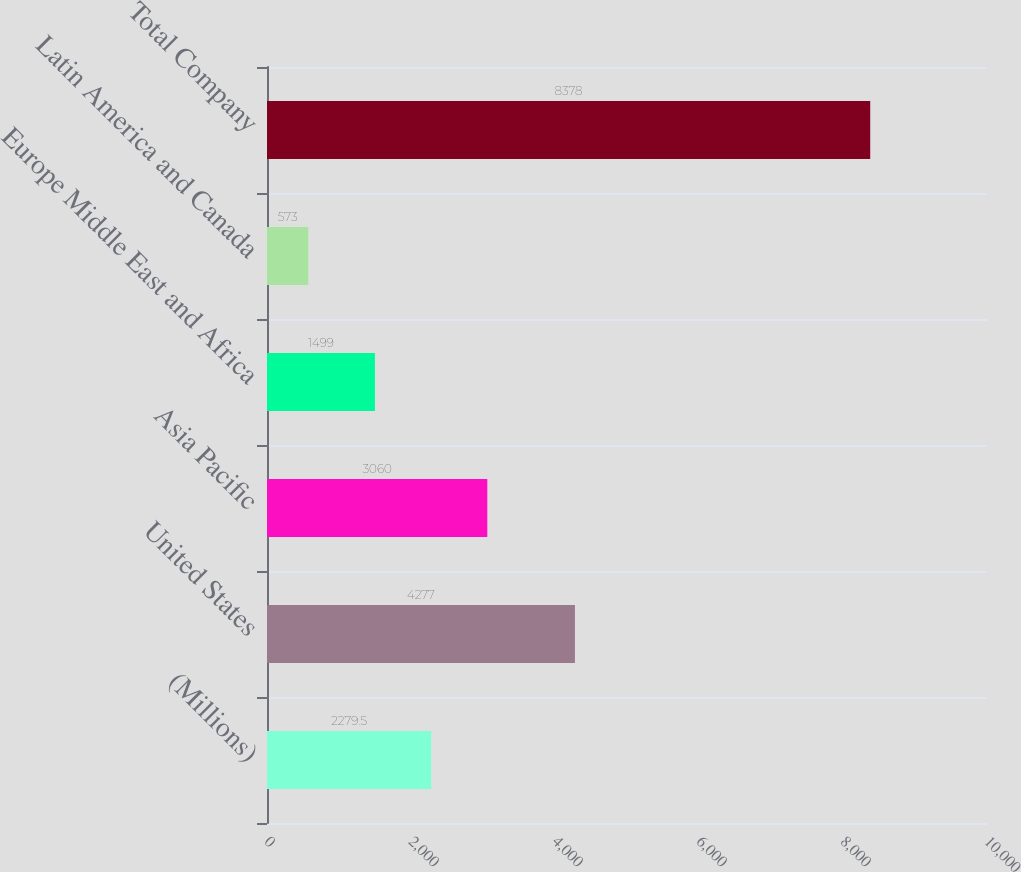Convert chart to OTSL. <chart><loc_0><loc_0><loc_500><loc_500><bar_chart><fcel>(Millions)<fcel>United States<fcel>Asia Pacific<fcel>Europe Middle East and Africa<fcel>Latin America and Canada<fcel>Total Company<nl><fcel>2279.5<fcel>4277<fcel>3060<fcel>1499<fcel>573<fcel>8378<nl></chart> 